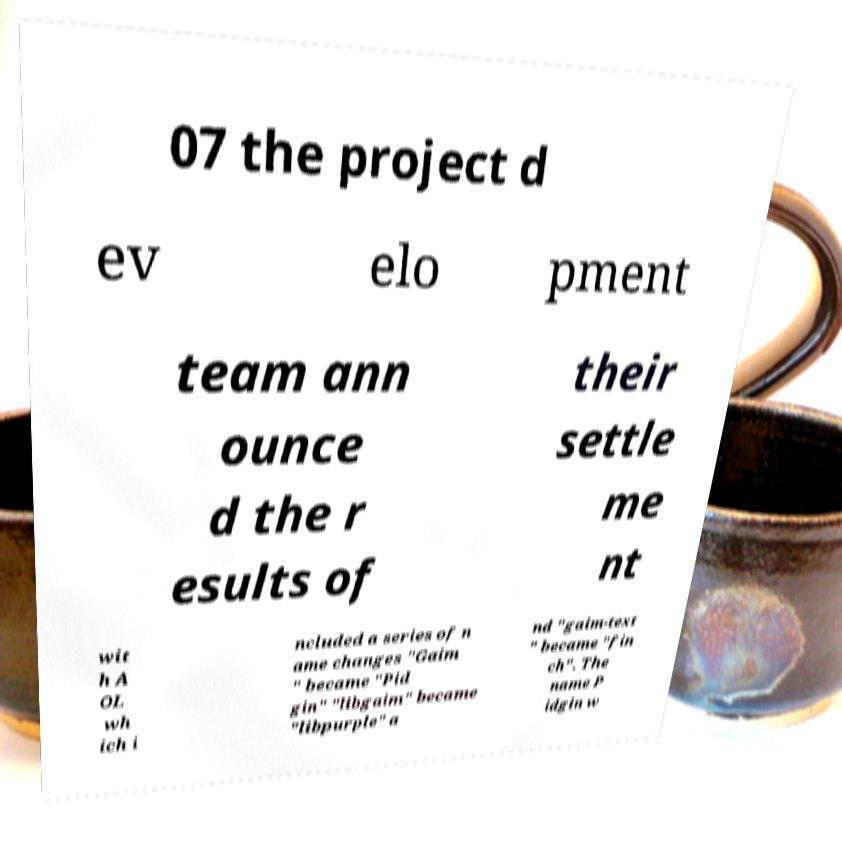Can you read and provide the text displayed in the image?This photo seems to have some interesting text. Can you extract and type it out for me? 07 the project d ev elo pment team ann ounce d the r esults of their settle me nt wit h A OL wh ich i ncluded a series of n ame changes "Gaim " became "Pid gin" "libgaim" became "libpurple" a nd "gaim-text " became "fin ch". The name P idgin w 